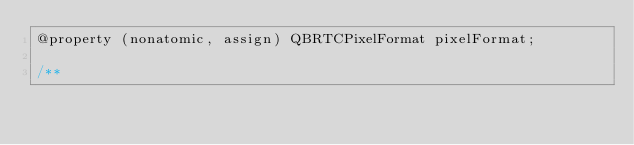<code> <loc_0><loc_0><loc_500><loc_500><_C_>@property (nonatomic, assign) QBRTCPixelFormat pixelFormat;

/**</code> 